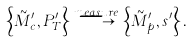<formula> <loc_0><loc_0><loc_500><loc_500>\left \{ \tilde { M } ^ { \prime } _ { c } , P ^ { \prime } _ { T } \right \} \stackrel { m e a s u r e } { \longrightarrow } \left \{ \tilde { M } ^ { \prime } _ { p } , s ^ { \prime } \right \} .</formula> 